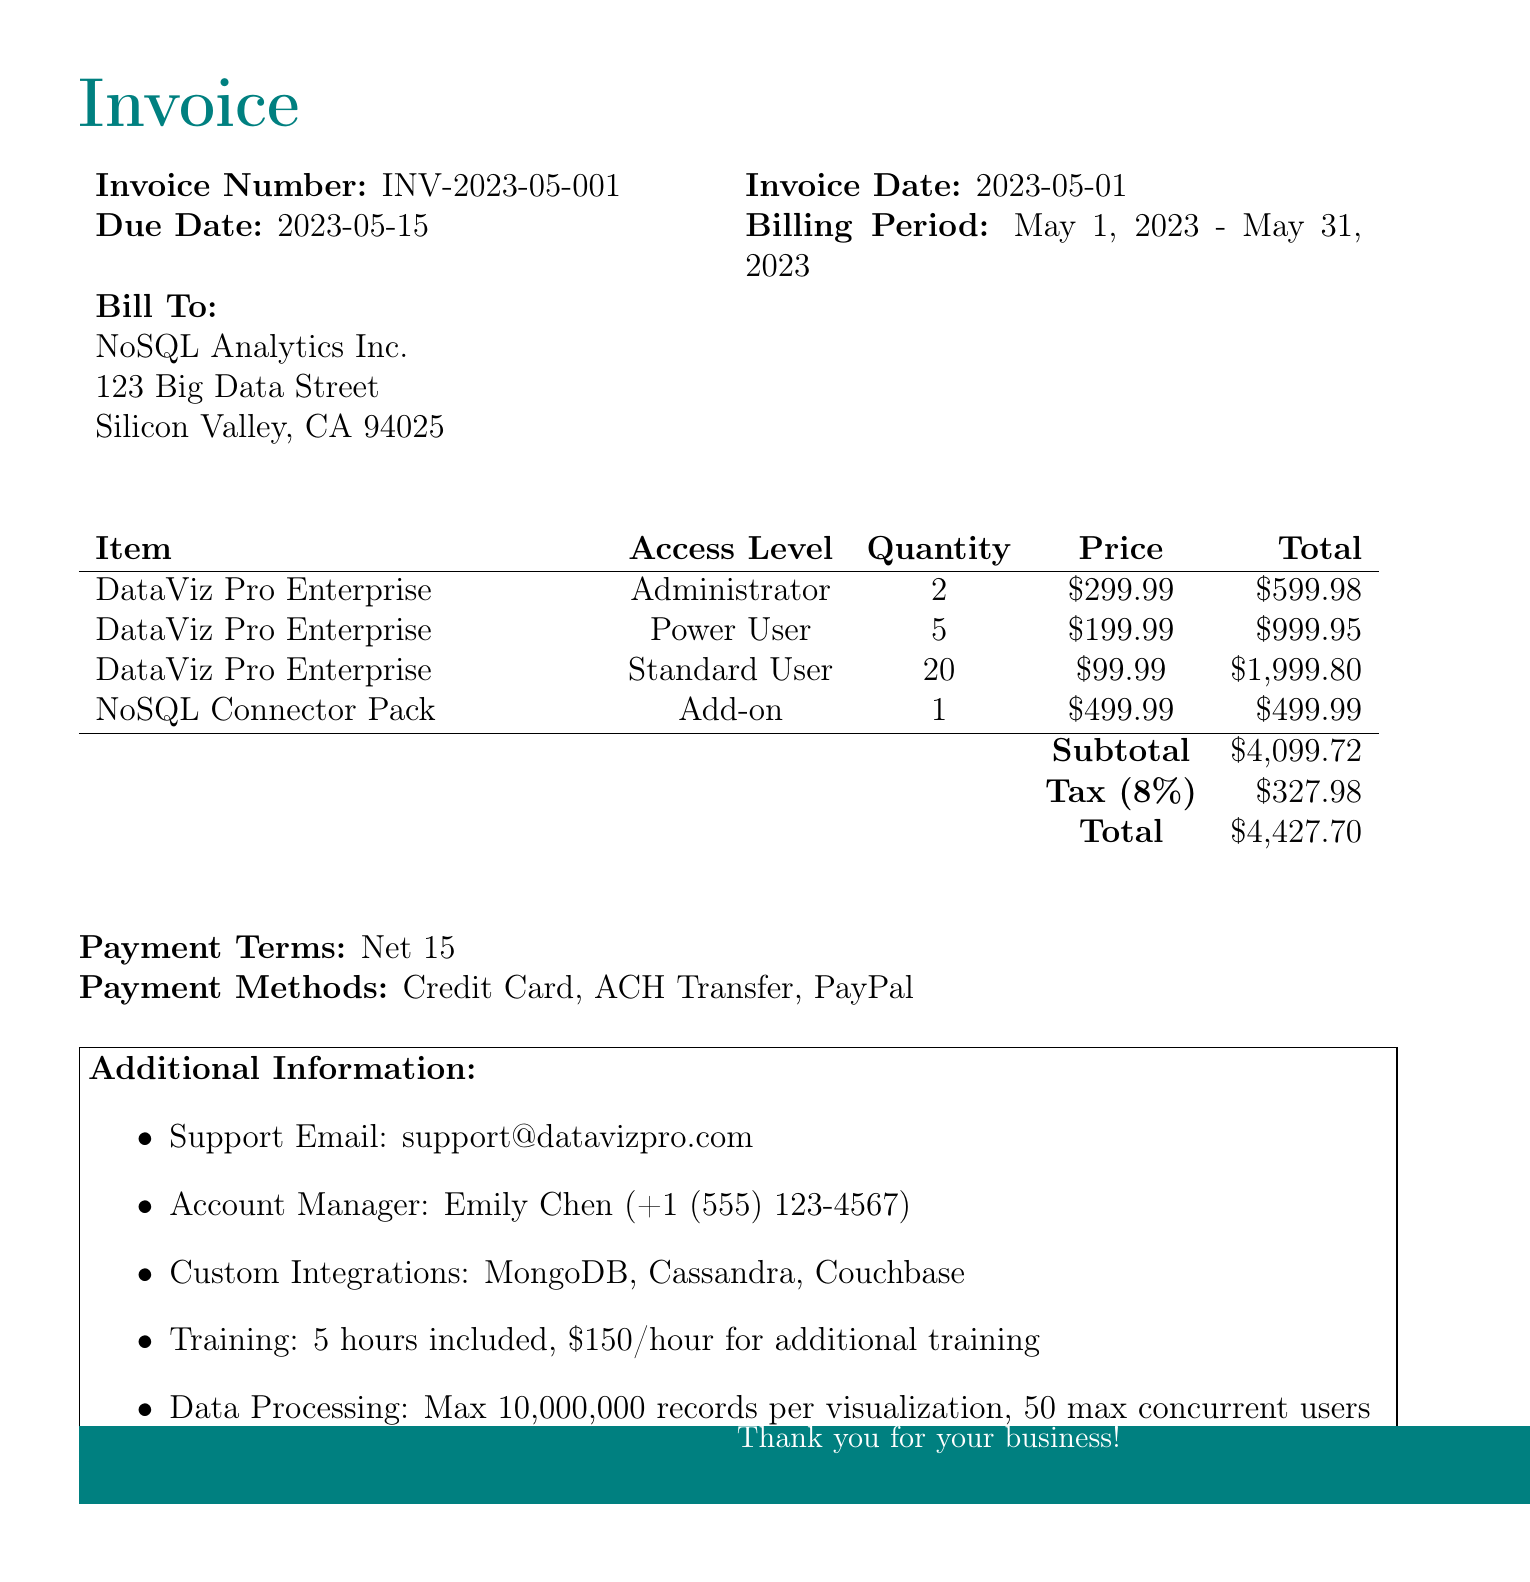What is the company name? The company name is the entity issuing the invoice, which is mentioned at the top of the document.
Answer: DataViz Pro What is the invoice number? The invoice number is a unique identifier for this billing statement, specified in the document.
Answer: INV-2023-05-001 What is the total amount due? The total amount due is the sum including subtotal and tax, highlighted in the total section of the invoice.
Answer: 4427.70 How many Standard User licenses were purchased? The quantity of Standard User licenses is stated in the license items section of the invoice.
Answer: 20 What is the tax rate applied to the invoice? The tax rate is provided in the subtotal section, indicating the percentage of taxation on the invoice total.
Answer: 8% Who is the account manager? The account manager's name is listed in the additional information section of the invoice.
Answer: Emily Chen What are the payment methods accepted? The accepted payment methods are specified in the relevant section of the invoice, showing the various ways to settle the bill.
Answer: Credit Card, ACH Transfer, PayPal What is the maximum number of concurrent users for data processing? The maximum number of concurrent users for data processing is detailed in the additional information about capacity.
Answer: 50 What is included in the training sessions? The included training sessions are mentioned in the additional information section, specifying the number of hours included.
Answer: 5 hours included 